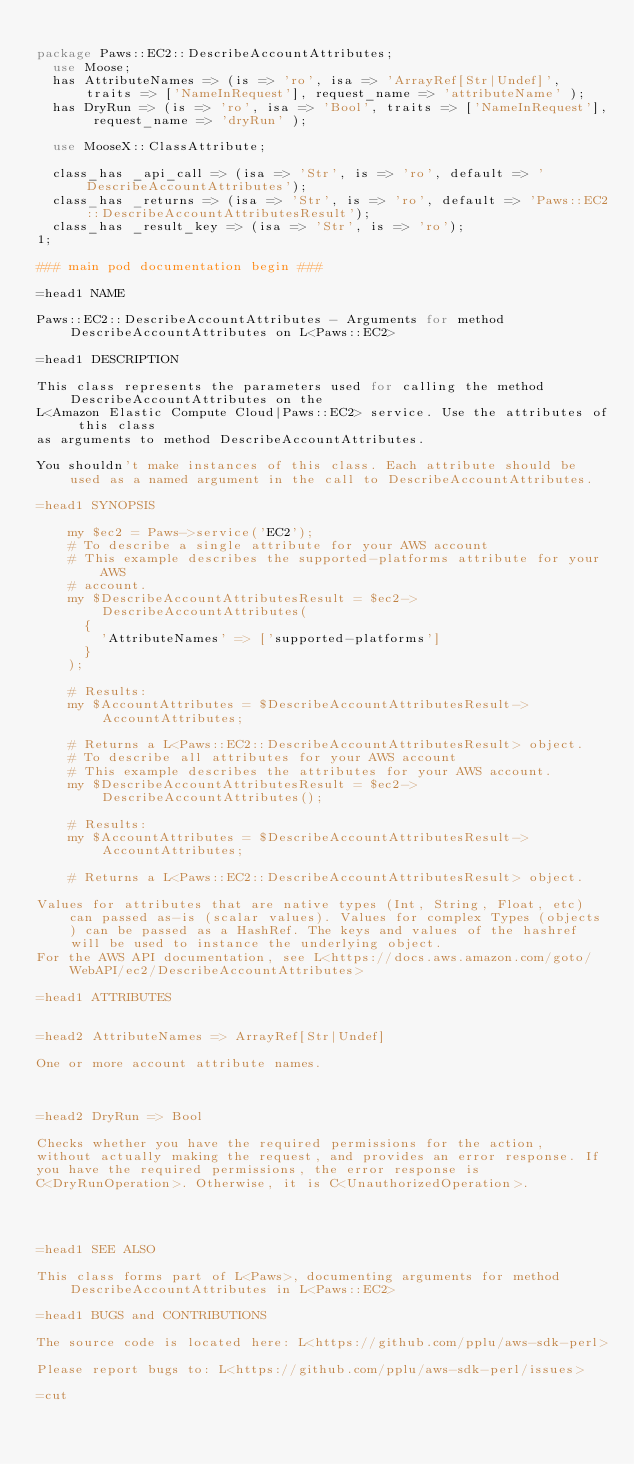<code> <loc_0><loc_0><loc_500><loc_500><_Perl_>
package Paws::EC2::DescribeAccountAttributes;
  use Moose;
  has AttributeNames => (is => 'ro', isa => 'ArrayRef[Str|Undef]', traits => ['NameInRequest'], request_name => 'attributeName' );
  has DryRun => (is => 'ro', isa => 'Bool', traits => ['NameInRequest'], request_name => 'dryRun' );

  use MooseX::ClassAttribute;

  class_has _api_call => (isa => 'Str', is => 'ro', default => 'DescribeAccountAttributes');
  class_has _returns => (isa => 'Str', is => 'ro', default => 'Paws::EC2::DescribeAccountAttributesResult');
  class_has _result_key => (isa => 'Str', is => 'ro');
1;

### main pod documentation begin ###

=head1 NAME

Paws::EC2::DescribeAccountAttributes - Arguments for method DescribeAccountAttributes on L<Paws::EC2>

=head1 DESCRIPTION

This class represents the parameters used for calling the method DescribeAccountAttributes on the
L<Amazon Elastic Compute Cloud|Paws::EC2> service. Use the attributes of this class
as arguments to method DescribeAccountAttributes.

You shouldn't make instances of this class. Each attribute should be used as a named argument in the call to DescribeAccountAttributes.

=head1 SYNOPSIS

    my $ec2 = Paws->service('EC2');
    # To describe a single attribute for your AWS account
    # This example describes the supported-platforms attribute for your AWS
    # account.
    my $DescribeAccountAttributesResult = $ec2->DescribeAccountAttributes(
      {
        'AttributeNames' => ['supported-platforms']
      }
    );

    # Results:
    my $AccountAttributes = $DescribeAccountAttributesResult->AccountAttributes;

    # Returns a L<Paws::EC2::DescribeAccountAttributesResult> object.
    # To describe all attributes for your AWS account
    # This example describes the attributes for your AWS account.
    my $DescribeAccountAttributesResult = $ec2->DescribeAccountAttributes();

    # Results:
    my $AccountAttributes = $DescribeAccountAttributesResult->AccountAttributes;

    # Returns a L<Paws::EC2::DescribeAccountAttributesResult> object.

Values for attributes that are native types (Int, String, Float, etc) can passed as-is (scalar values). Values for complex Types (objects) can be passed as a HashRef. The keys and values of the hashref will be used to instance the underlying object.
For the AWS API documentation, see L<https://docs.aws.amazon.com/goto/WebAPI/ec2/DescribeAccountAttributes>

=head1 ATTRIBUTES


=head2 AttributeNames => ArrayRef[Str|Undef]

One or more account attribute names.



=head2 DryRun => Bool

Checks whether you have the required permissions for the action,
without actually making the request, and provides an error response. If
you have the required permissions, the error response is
C<DryRunOperation>. Otherwise, it is C<UnauthorizedOperation>.




=head1 SEE ALSO

This class forms part of L<Paws>, documenting arguments for method DescribeAccountAttributes in L<Paws::EC2>

=head1 BUGS and CONTRIBUTIONS

The source code is located here: L<https://github.com/pplu/aws-sdk-perl>

Please report bugs to: L<https://github.com/pplu/aws-sdk-perl/issues>

=cut

</code> 